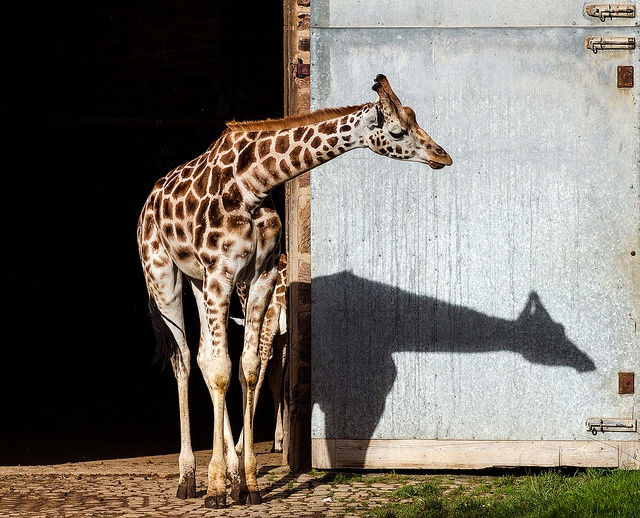Describe the objects in this image and their specific colors. I can see a giraffe in black, ivory, maroon, and tan tones in this image. 